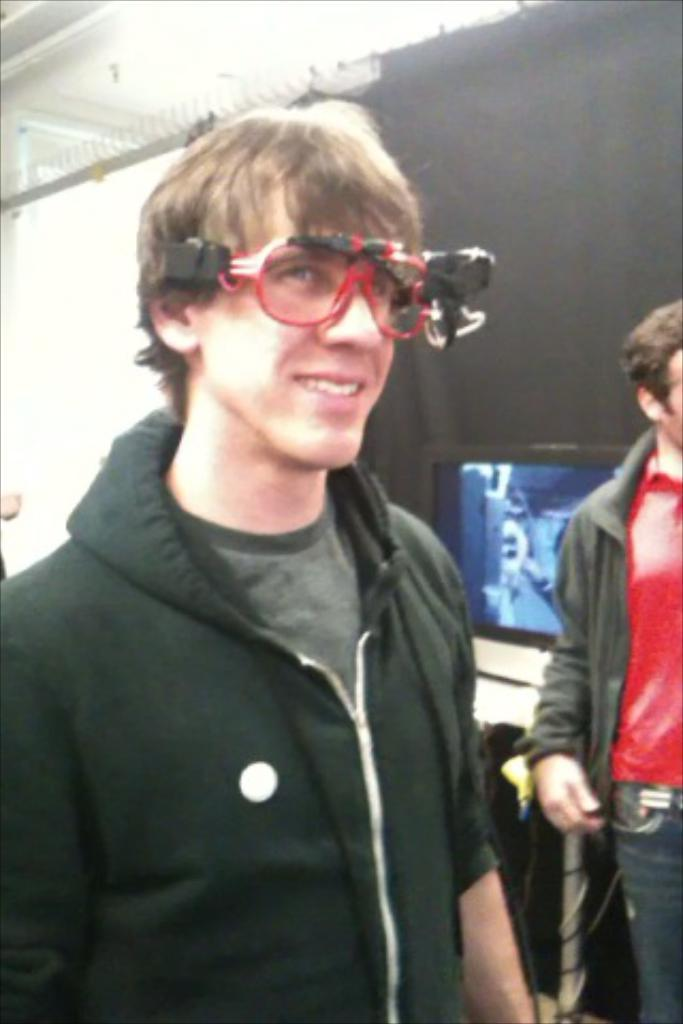How many men are present in the image? There are two men standing in the image. What can be observed about the men's attire? Both men are wearing clothes. Can you describe the facial expression of the man on the left side? The man on the left side is smiling. What accessory is the man on the left side wearing? The man on the left side is wearing spectacles. What is one of the objects visible in the image? There is a screen visible in the image. What type of window treatment is present in the image? There are black curtains in the image. What type of government is depicted in the image? There is no depiction of a government in the image; it features include two men, their attire, facial expressions, and accessories, as well as a screen and black curtains. Is there a guitar visible in the image? No, there is no guitar present in the image. 